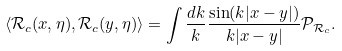<formula> <loc_0><loc_0><loc_500><loc_500>\langle \mathcal { R } _ { c } ( x , \eta ) , \mathcal { R } _ { c } ( y , \eta ) \rangle = \int \frac { d k } { k } \frac { \sin ( k | x - y | ) } { k | x - y | } \mathcal { P } _ { \mathcal { R } _ { c } } .</formula> 